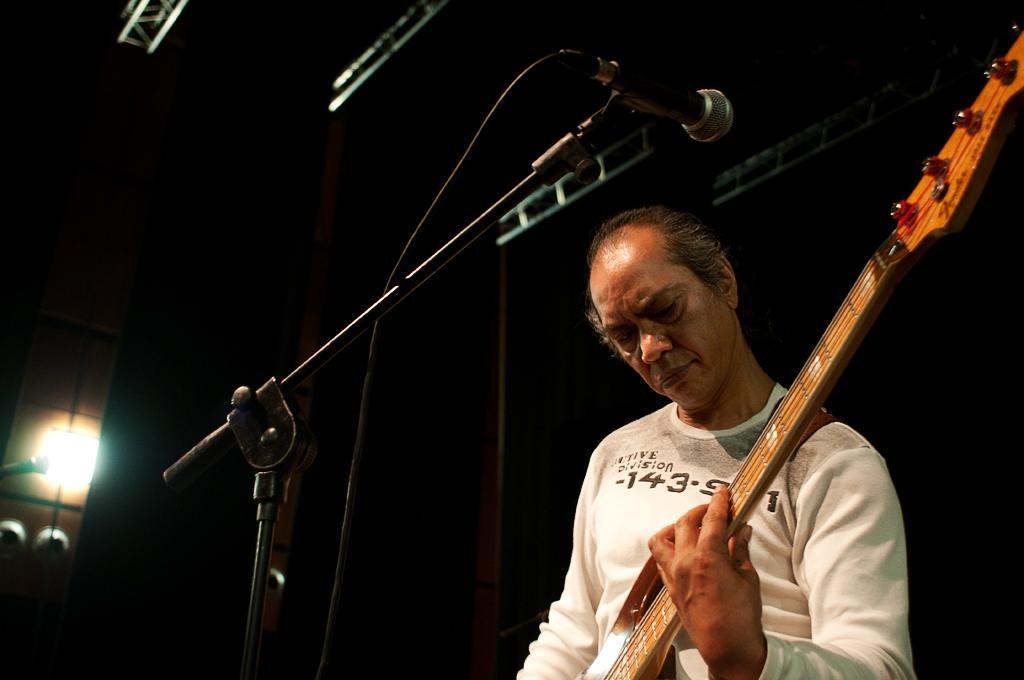Could you give a brief overview of what you see in this image? In this picture we can see a man wearing white t-shirt and playing guitar. In the front there is a microphone stand. Behind there is a dark background. 